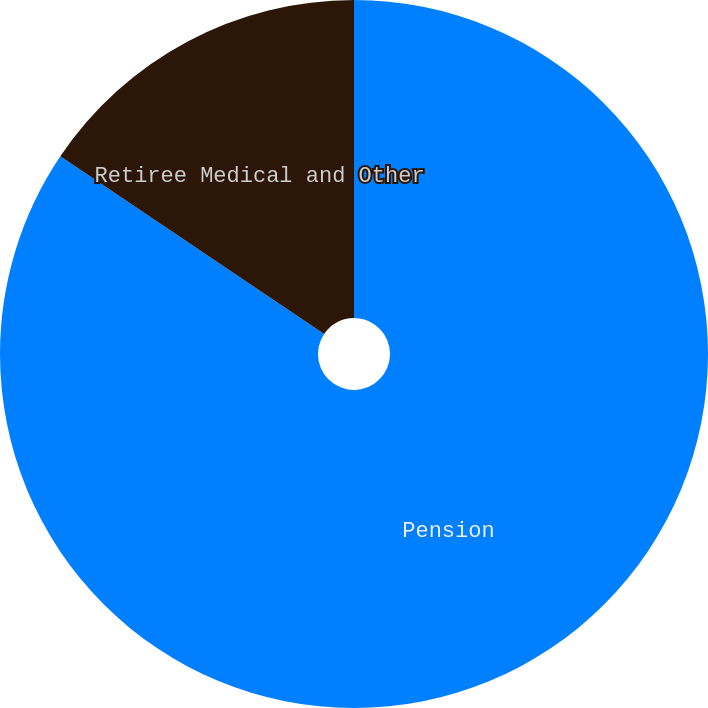Convert chart. <chart><loc_0><loc_0><loc_500><loc_500><pie_chart><fcel>Pension<fcel>Retiree Medical and Other<nl><fcel>84.43%<fcel>15.57%<nl></chart> 